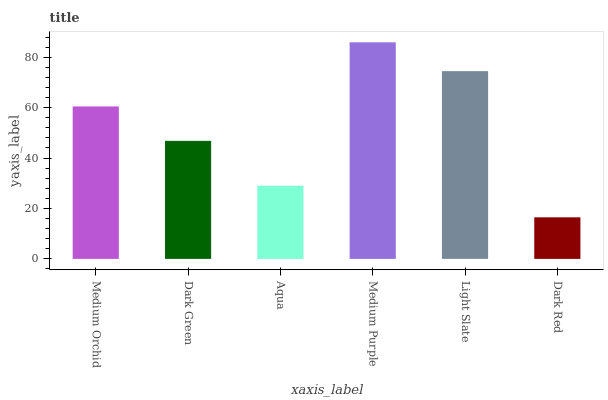Is Dark Red the minimum?
Answer yes or no. Yes. Is Medium Purple the maximum?
Answer yes or no. Yes. Is Dark Green the minimum?
Answer yes or no. No. Is Dark Green the maximum?
Answer yes or no. No. Is Medium Orchid greater than Dark Green?
Answer yes or no. Yes. Is Dark Green less than Medium Orchid?
Answer yes or no. Yes. Is Dark Green greater than Medium Orchid?
Answer yes or no. No. Is Medium Orchid less than Dark Green?
Answer yes or no. No. Is Medium Orchid the high median?
Answer yes or no. Yes. Is Dark Green the low median?
Answer yes or no. Yes. Is Light Slate the high median?
Answer yes or no. No. Is Aqua the low median?
Answer yes or no. No. 